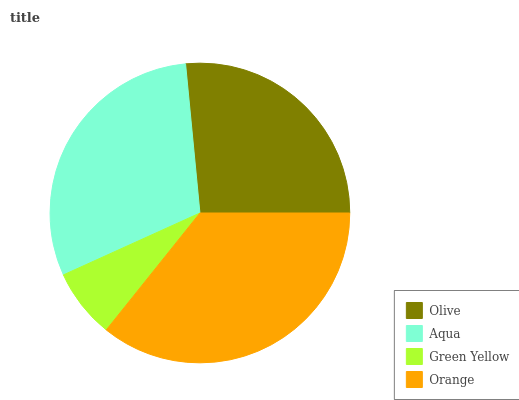Is Green Yellow the minimum?
Answer yes or no. Yes. Is Orange the maximum?
Answer yes or no. Yes. Is Aqua the minimum?
Answer yes or no. No. Is Aqua the maximum?
Answer yes or no. No. Is Aqua greater than Olive?
Answer yes or no. Yes. Is Olive less than Aqua?
Answer yes or no. Yes. Is Olive greater than Aqua?
Answer yes or no. No. Is Aqua less than Olive?
Answer yes or no. No. Is Aqua the high median?
Answer yes or no. Yes. Is Olive the low median?
Answer yes or no. Yes. Is Orange the high median?
Answer yes or no. No. Is Aqua the low median?
Answer yes or no. No. 